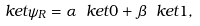Convert formula to latex. <formula><loc_0><loc_0><loc_500><loc_500>\ k e t { \psi } _ { R } = \alpha \ k e t { 0 } + \beta \ k e t { 1 } ,</formula> 